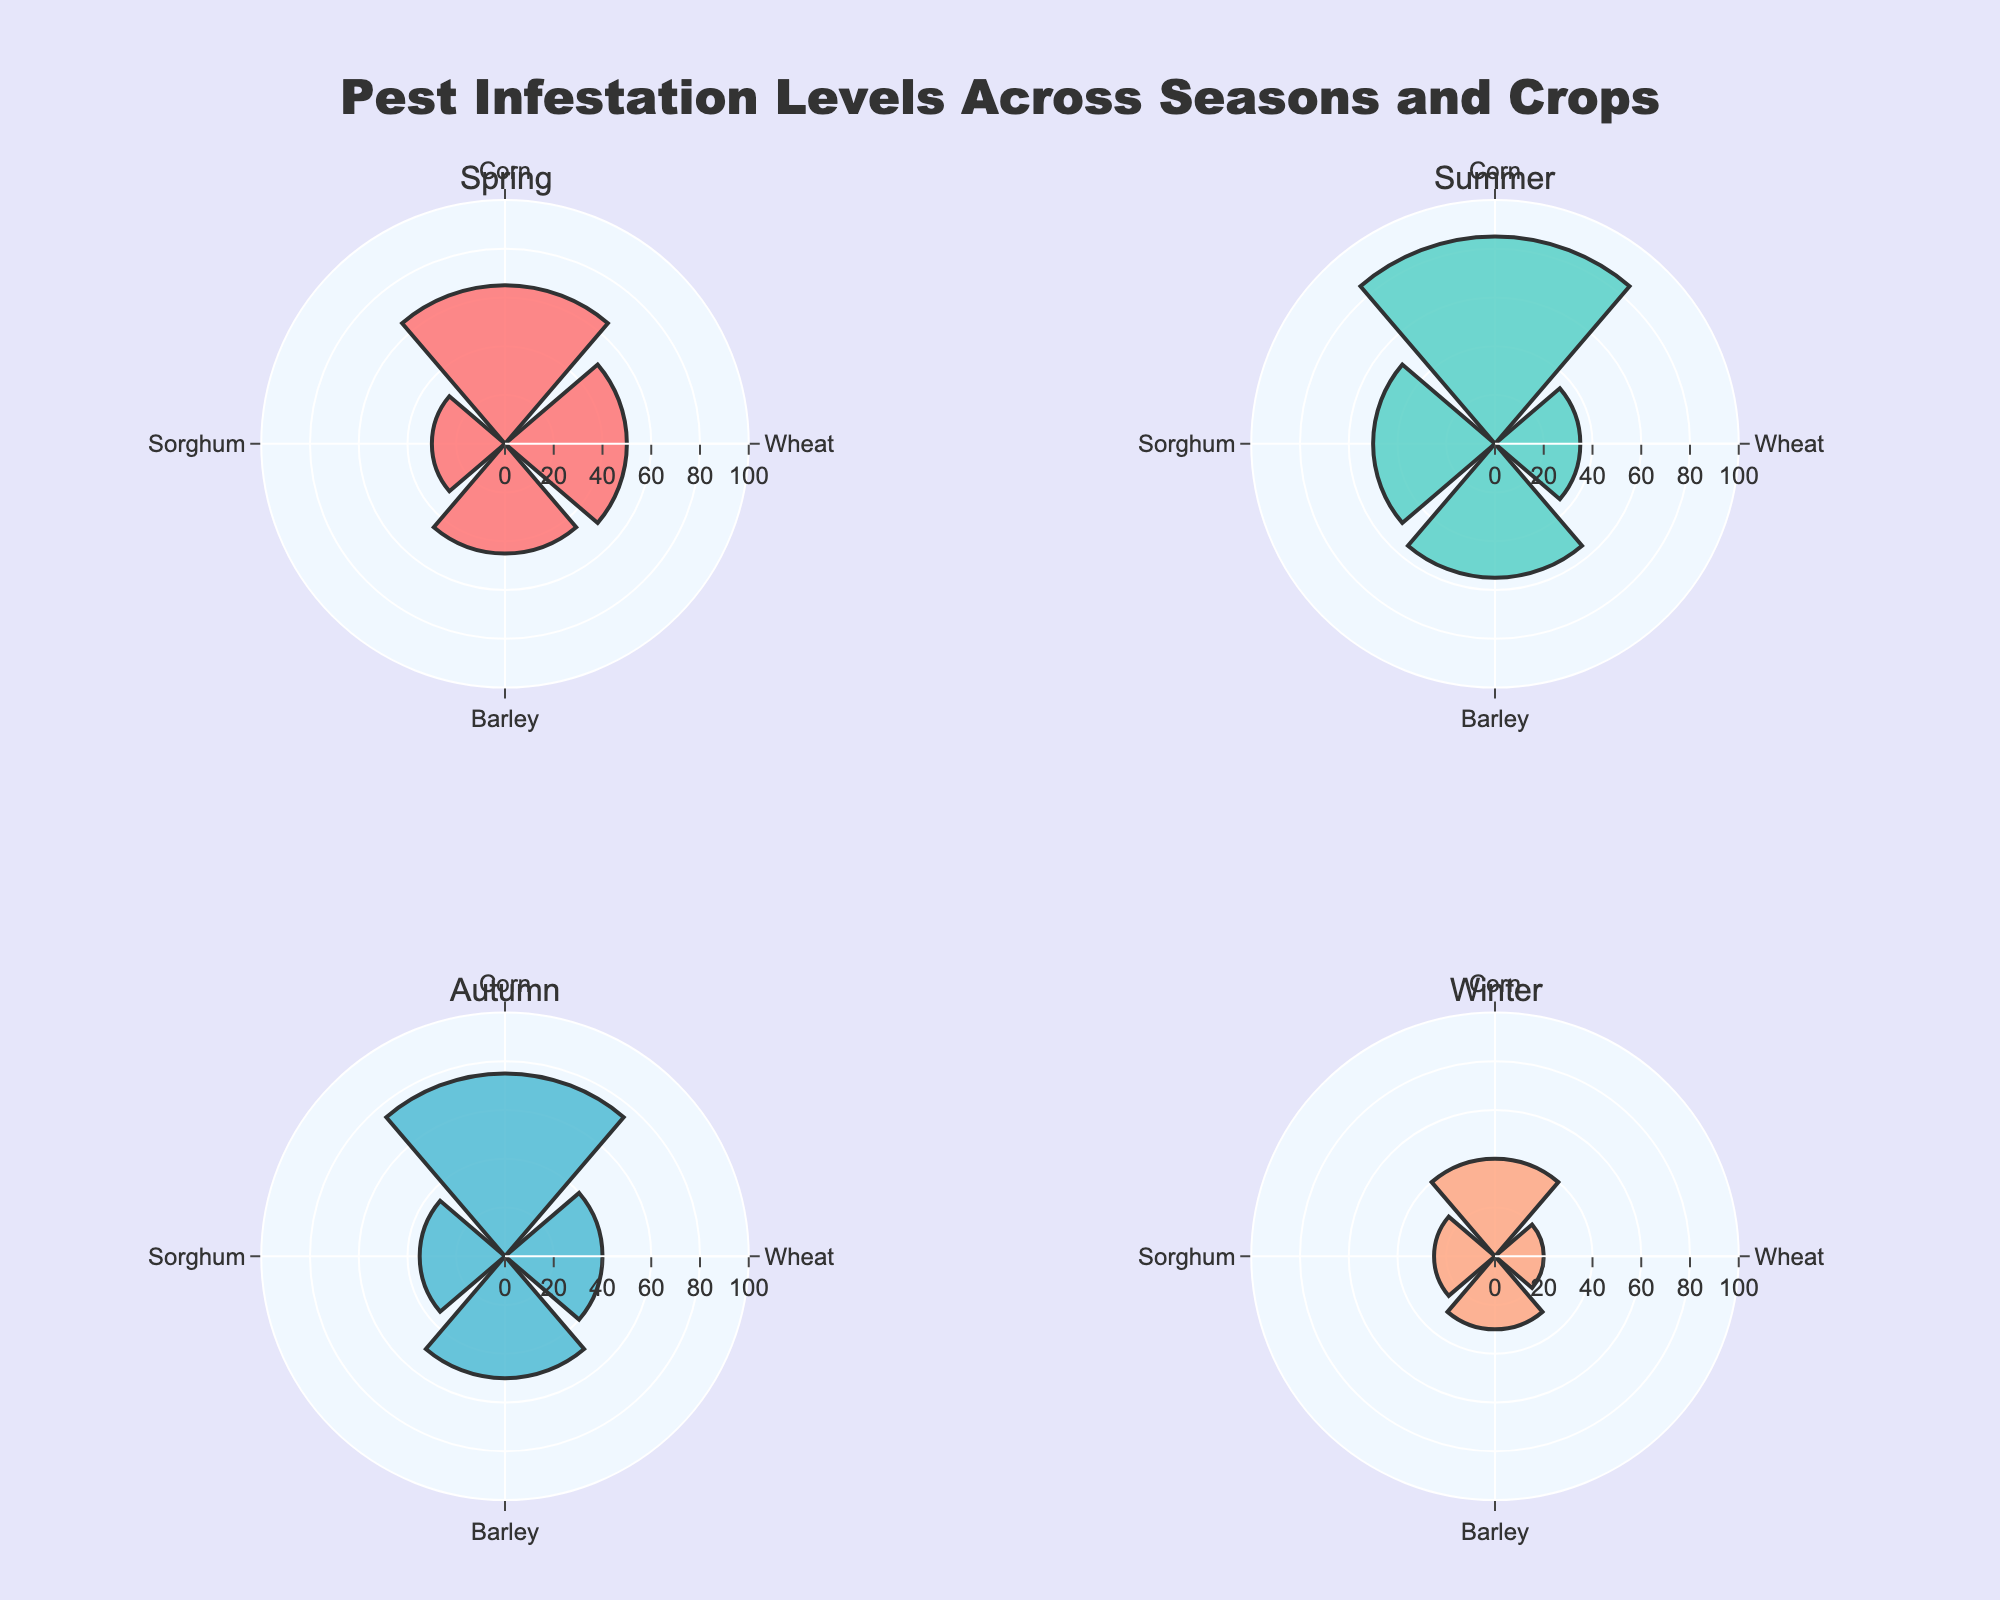What's the title of the figure? The title is usually found at the top of the figure. Here, it reads, "Pest Infestation Levels Across Seasons and Crops," indicating what the data visualization is about.
Answer: Pest Infestation Levels Across Seasons and Crops What are the four crop types represented in this figure? Looking at the labels on the polar axes, we can see the four crop types: Wheat, Corn, Sorghum, and Barley. These labels are repeated in each subplot corresponding to different seasons.
Answer: Wheat, Corn, Sorghum, Barley Which crop had the highest pest infestation level in Summer? In the Summer subplot, the bar extending farthest from the center corresponds to Corn. Thus, Corn in Summer has the highest level of pest infestation.
Answer: Corn What's the range of the radial axis in the subplots? The radial axis range can be deduced by noticing the labeled ticks, which span from 0 to 100. This is consistent across all polar subplots.
Answer: 0 to 100 What is the pest infestation level for Barley during Winter? To find this, look at the Winter subplot and find the bar extending from 'Barley.' The radial value of this bar is 30.
Answer: 30 Which season had the highest pest infestation levels across the different crop types? By observing the subplots, Summer shows the highest bars overall, with Corn peaking notably high. This indicates that pest infestation levels across crop types were highest in Summer.
Answer: Summer Compare the pest infestation levels of Corn between Spring and Autumn. Which season has a higher level? In the Spring subplot, Corn's infestation level is given by a radial value of 65. In the Autumn subplot, Corn has a value of 75. Therefore, Corn has a higher pest infestation level in Autumn.
Answer: Autumn What is the average pest infestation level for Sorghum across all seasons? To find the average, add the infestation levels of Sorghum in all seasons and divide by the number of seasons. Level values are 30 (Spring), 50 (Summer), 35 (Autumn), and 25 (Winter). The sum is 140, and there are 4 seasons, so the average is 140/4.
Answer: 35 